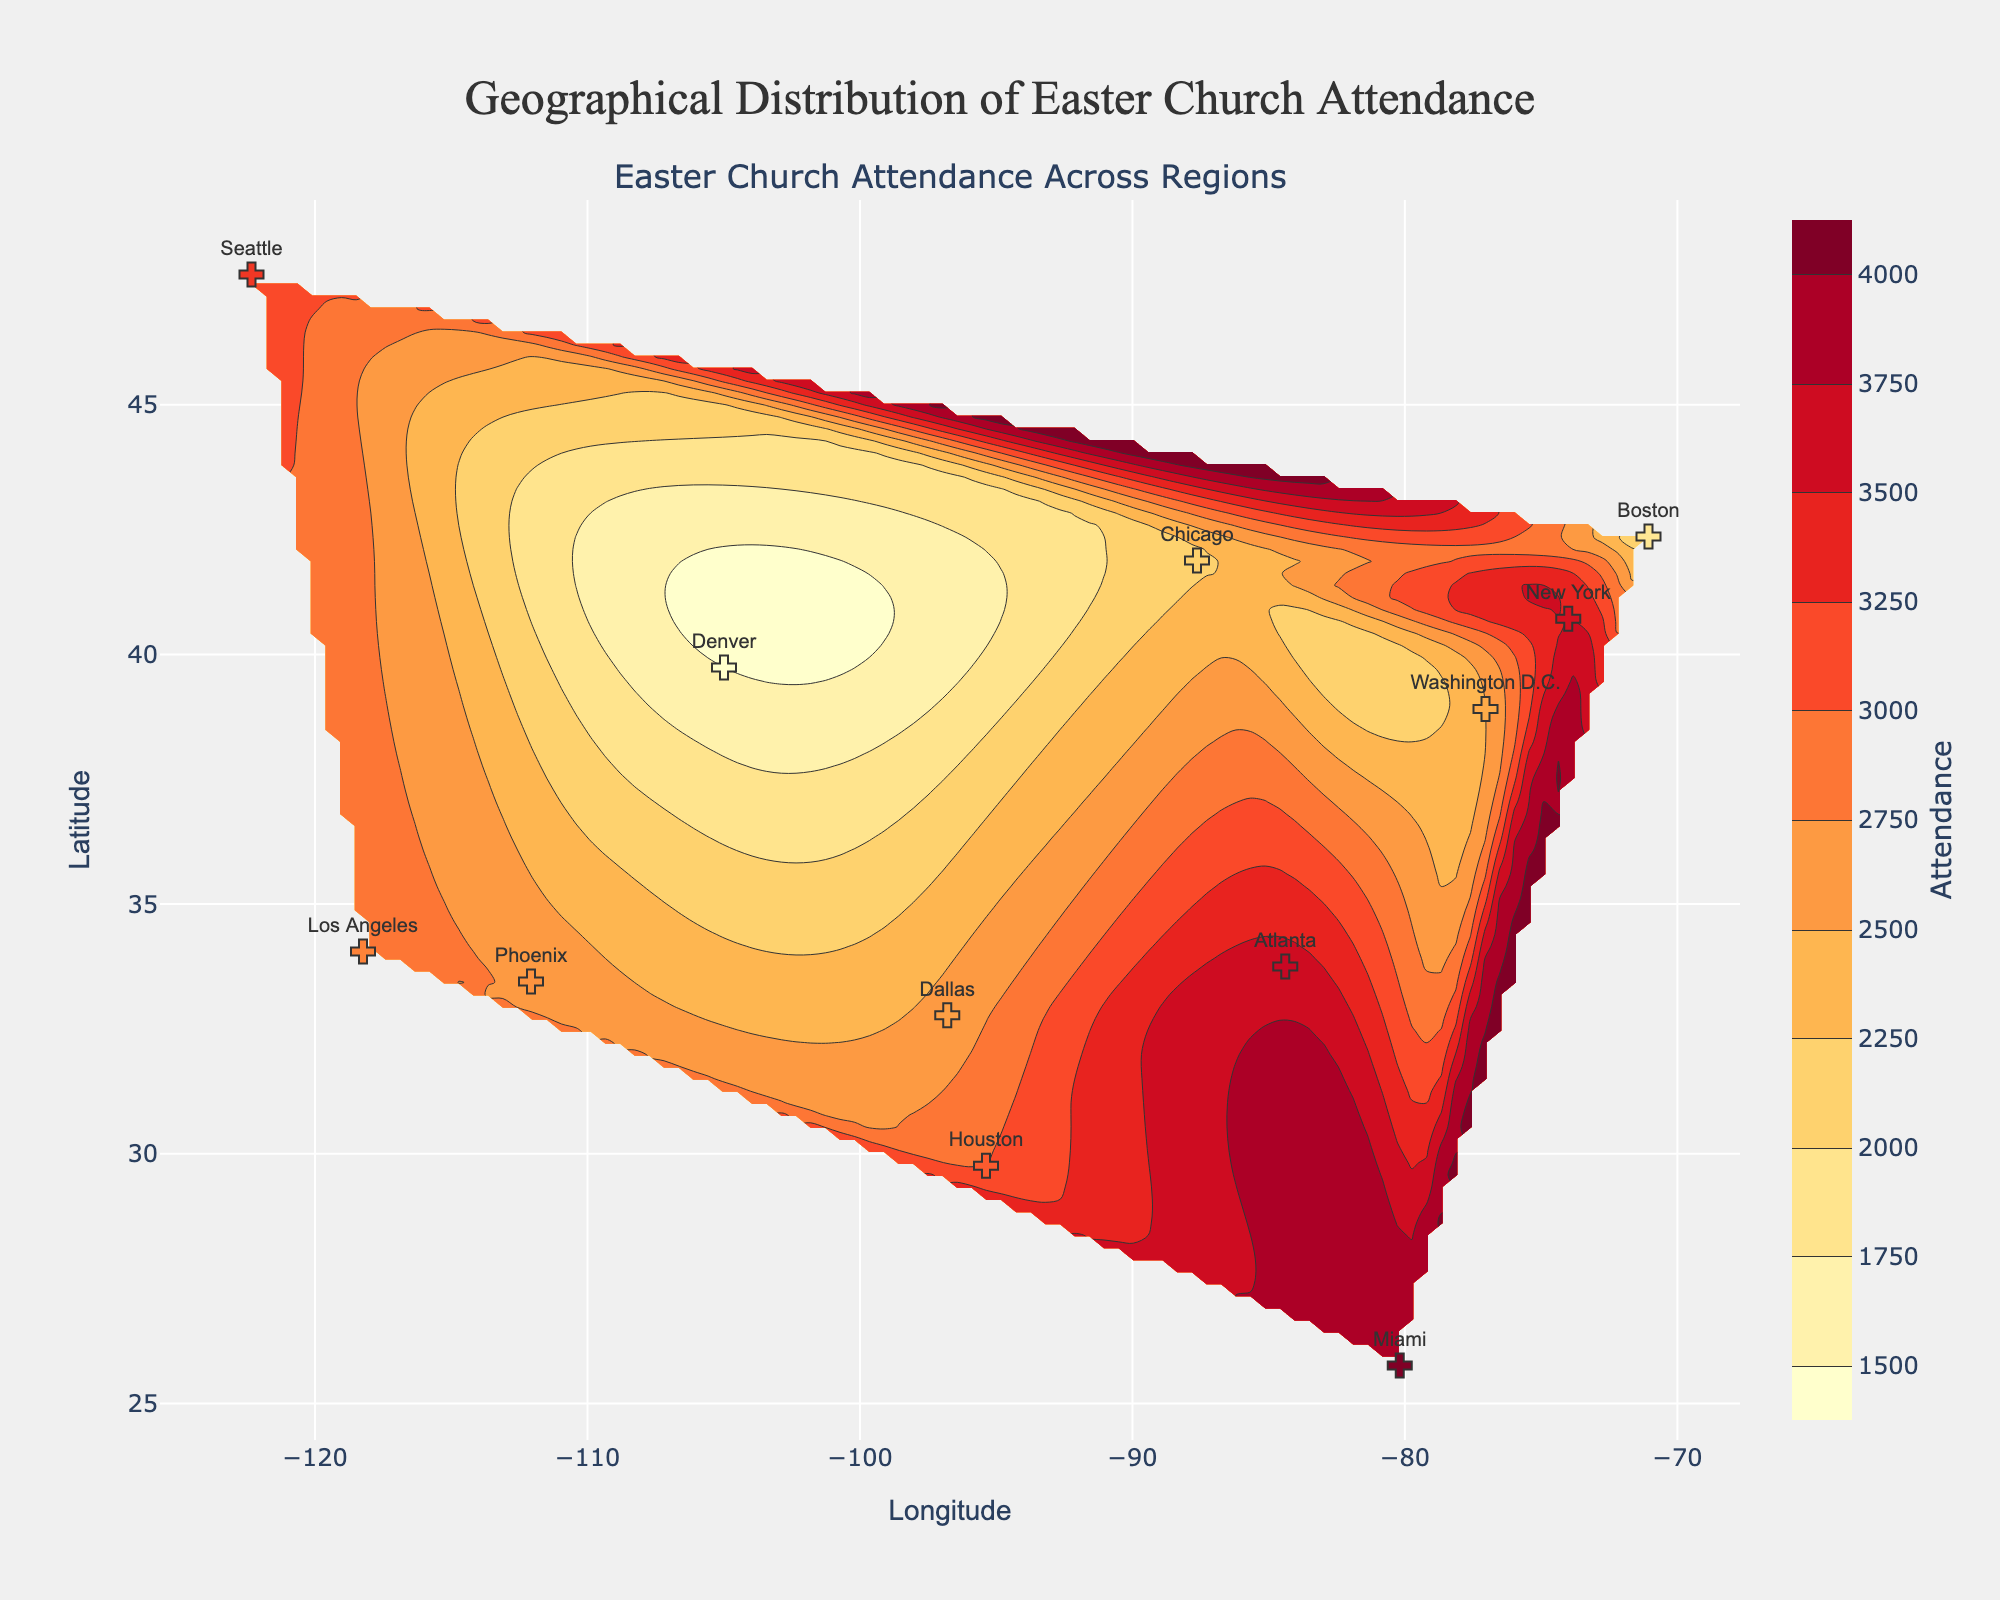What is the title of the figure? The title is displayed at the top of the figure and reads "Geographical Distribution of Easter Church Attendance."
Answer: Geographical Distribution of Easter Church Attendance Which city shows the highest attendance on Easter according to the figure? The contour and markers depict the attendance for different cities, and the highest marker indicated by color intensity and value is Miami.
Answer: Miami What are the units used for the x and y axes? The x-axis is labeled with "Longitude" and the y-axis with "Latitude," implying that they represent geographical coordinates.
Answer: Longitude (x-axis) and Latitude (y-axis) Which city has the lowest church attendance? By examining the scattered markers and noting their colors and positioning, Denver, with a church attendance of 1500, has the lowest value.
Answer: Denver Compare the church attendances of New York and Los Angeles. Which has a higher attendance? By comparing the markers' color intensity and values, New York has an attendance of 3500, while Los Angeles has 2800. Therefore, New York has a higher attendance.
Answer: New York What is the range of church attendance values represented on the color bar? The color bar alongside the contour plot starts at 1500 and ends at 4000, indicating the range of attendance values.
Answer: 1500 to 4000 Which three cities have a church attendance of over 3000? By identifying the markers with attendance values over 3000 near the top of the color scale, the cities are New York, Miami, and Seattle.
Answer: New York, Miami, Seattle How does the church attendance in Atlanta compare with that of Washington D.C.? By examining the scatter markers, Atlanta has an attendance of 3600, whereas Washington D.C. has 2500. Thus, Atlanta has a higher attendance than Washington D.C.
Answer: Atlanta List the cities located east of -90 longitude. Examining the scatter plot for longitude values greater than -90, the cities are New York, Miami, Boston, Atlanta, and Washington D.C.
Answer: New York, Miami, Boston, Atlanta, Washington D.C What is the attendance value at the contour point closest to Dallas? Observing the contour plot and the position of Dallas on the scatter, the closest contour levels range near the attendance value of 2600 for Dallas.
Answer: 2600 